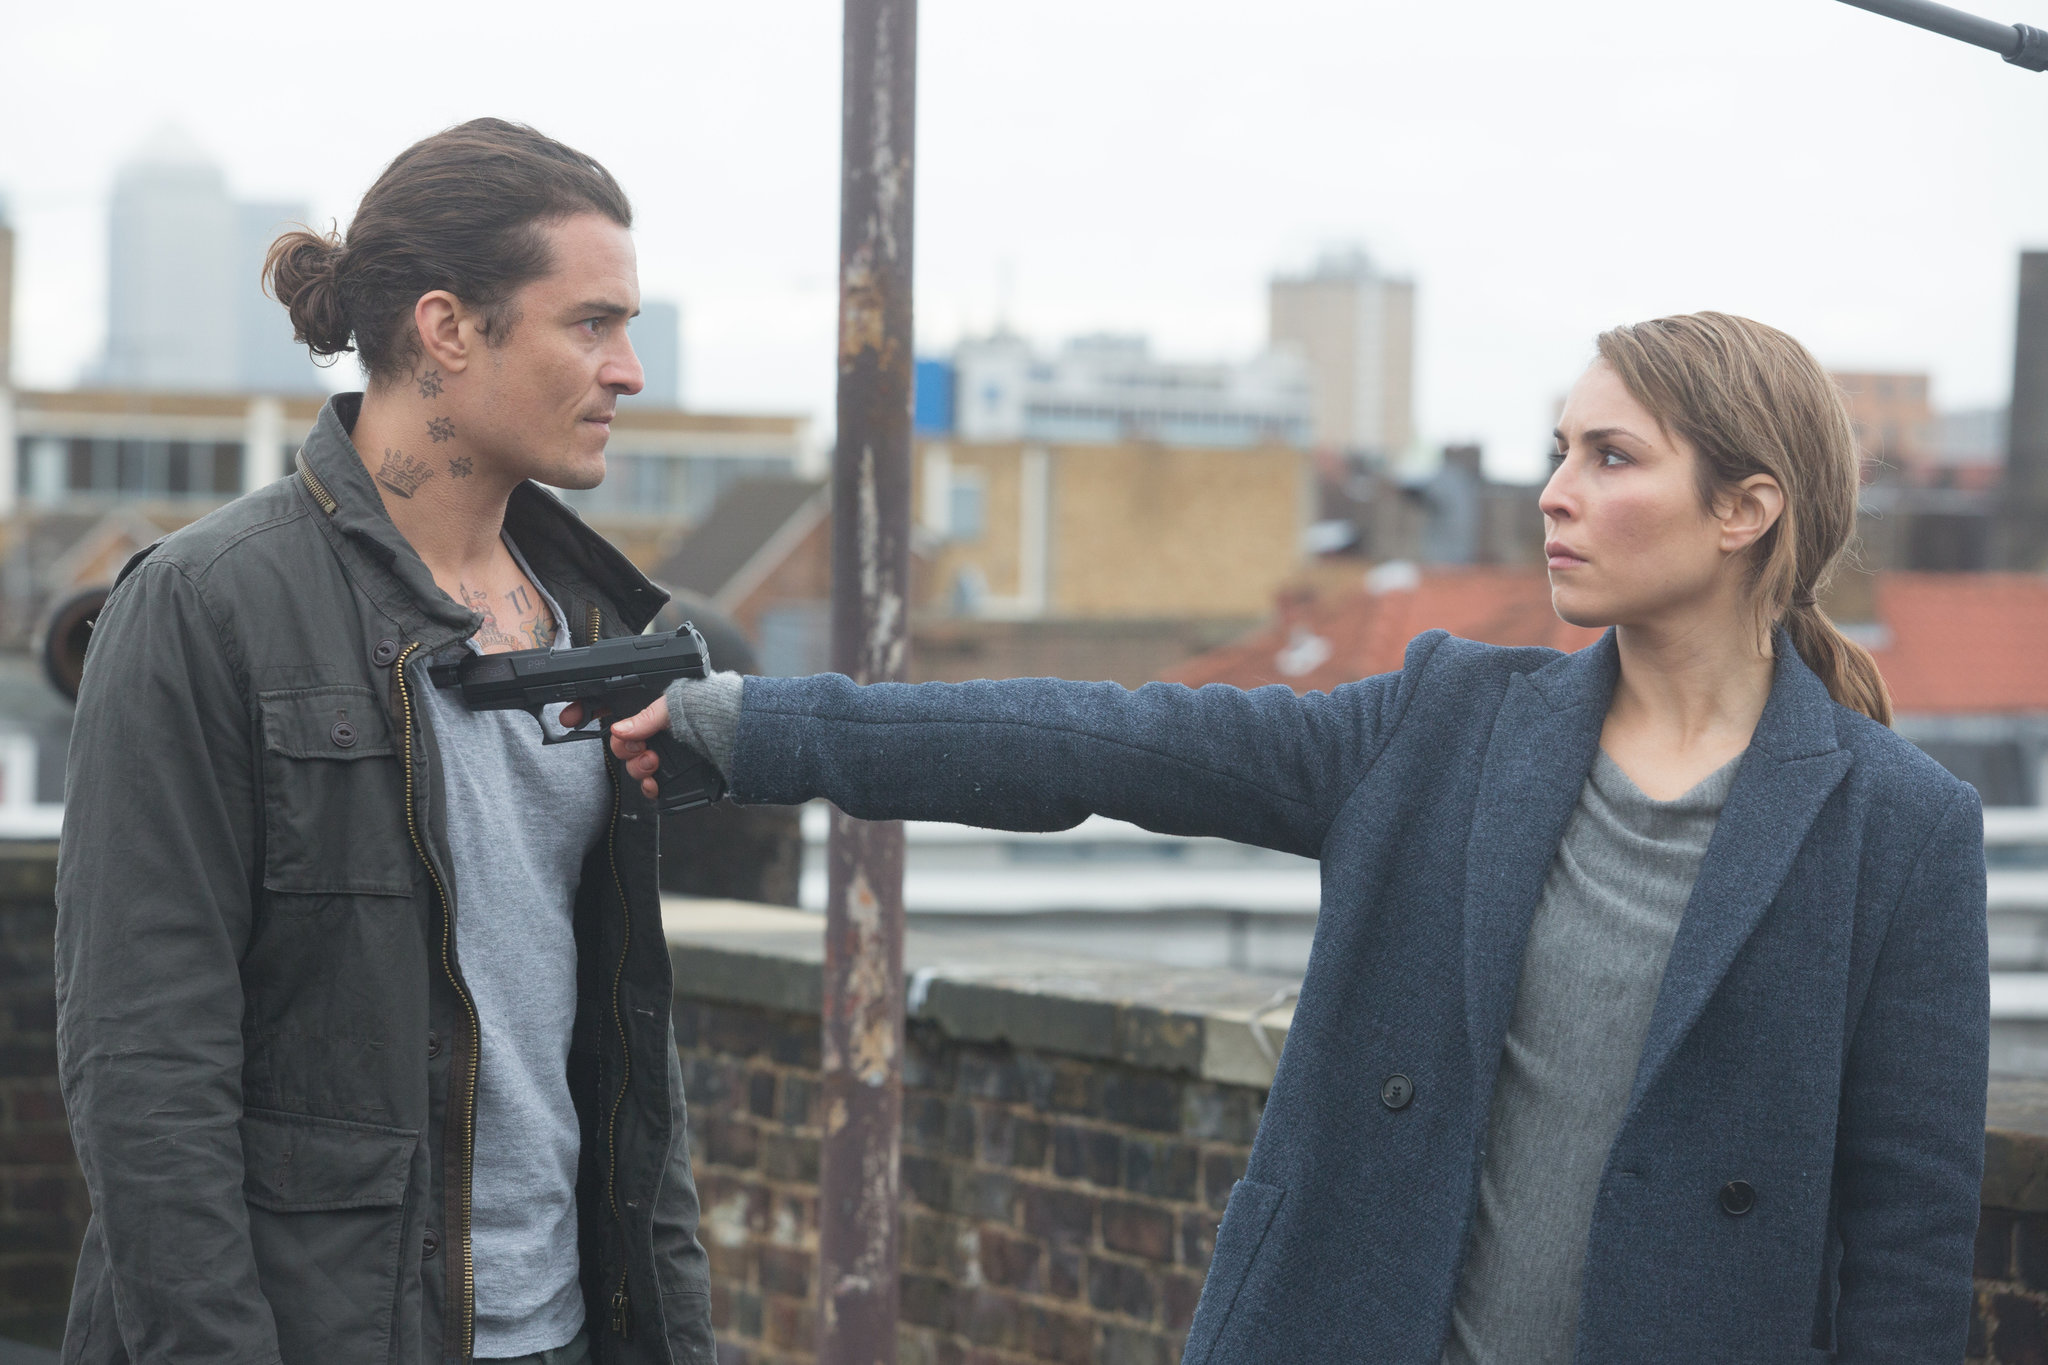Describe the following image. This striking image captures an intense moment on a rooftop. The actress, likely Noomi Rapace playing the character sharegpt4v/sam from the movie 'Close,' is sternly pointing a gun at a man in front of her. The man, distinguishable by his green jacket and neck tattoos, faces her with a calm demeanor. The backdrop features a city skyline, reinforcing the tension of this urban confrontation. sharegpt4v/sam’s unwavering focus and the palpable tension between the two characters make this scene extremely compelling. 